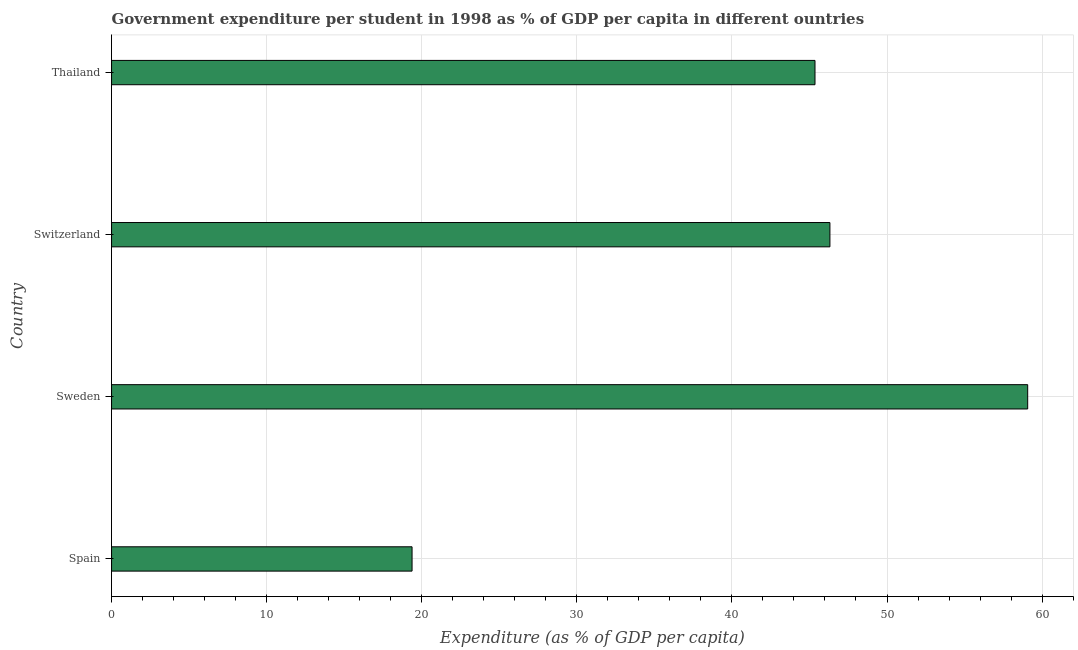Does the graph contain any zero values?
Keep it short and to the point. No. What is the title of the graph?
Keep it short and to the point. Government expenditure per student in 1998 as % of GDP per capita in different ountries. What is the label or title of the X-axis?
Your response must be concise. Expenditure (as % of GDP per capita). What is the label or title of the Y-axis?
Give a very brief answer. Country. What is the government expenditure per student in Switzerland?
Give a very brief answer. 46.32. Across all countries, what is the maximum government expenditure per student?
Your answer should be compact. 59.07. Across all countries, what is the minimum government expenditure per student?
Your answer should be very brief. 19.38. What is the sum of the government expenditure per student?
Keep it short and to the point. 170.12. What is the difference between the government expenditure per student in Sweden and Thailand?
Your response must be concise. 13.71. What is the average government expenditure per student per country?
Your answer should be very brief. 42.53. What is the median government expenditure per student?
Provide a short and direct response. 45.84. In how many countries, is the government expenditure per student greater than 58 %?
Ensure brevity in your answer.  1. Is the government expenditure per student in Spain less than that in Thailand?
Your answer should be compact. Yes. What is the difference between the highest and the second highest government expenditure per student?
Keep it short and to the point. 12.75. What is the difference between the highest and the lowest government expenditure per student?
Give a very brief answer. 39.7. Are all the bars in the graph horizontal?
Ensure brevity in your answer.  Yes. How many countries are there in the graph?
Your answer should be compact. 4. What is the difference between two consecutive major ticks on the X-axis?
Make the answer very short. 10. Are the values on the major ticks of X-axis written in scientific E-notation?
Provide a succinct answer. No. What is the Expenditure (as % of GDP per capita) of Spain?
Provide a succinct answer. 19.38. What is the Expenditure (as % of GDP per capita) in Sweden?
Your response must be concise. 59.07. What is the Expenditure (as % of GDP per capita) in Switzerland?
Ensure brevity in your answer.  46.32. What is the Expenditure (as % of GDP per capita) in Thailand?
Your answer should be very brief. 45.36. What is the difference between the Expenditure (as % of GDP per capita) in Spain and Sweden?
Provide a succinct answer. -39.7. What is the difference between the Expenditure (as % of GDP per capita) in Spain and Switzerland?
Provide a short and direct response. -26.94. What is the difference between the Expenditure (as % of GDP per capita) in Spain and Thailand?
Your response must be concise. -25.98. What is the difference between the Expenditure (as % of GDP per capita) in Sweden and Switzerland?
Your answer should be compact. 12.75. What is the difference between the Expenditure (as % of GDP per capita) in Sweden and Thailand?
Provide a succinct answer. 13.71. What is the difference between the Expenditure (as % of GDP per capita) in Switzerland and Thailand?
Offer a very short reply. 0.96. What is the ratio of the Expenditure (as % of GDP per capita) in Spain to that in Sweden?
Keep it short and to the point. 0.33. What is the ratio of the Expenditure (as % of GDP per capita) in Spain to that in Switzerland?
Your response must be concise. 0.42. What is the ratio of the Expenditure (as % of GDP per capita) in Spain to that in Thailand?
Ensure brevity in your answer.  0.43. What is the ratio of the Expenditure (as % of GDP per capita) in Sweden to that in Switzerland?
Your response must be concise. 1.27. What is the ratio of the Expenditure (as % of GDP per capita) in Sweden to that in Thailand?
Provide a succinct answer. 1.3. What is the ratio of the Expenditure (as % of GDP per capita) in Switzerland to that in Thailand?
Keep it short and to the point. 1.02. 